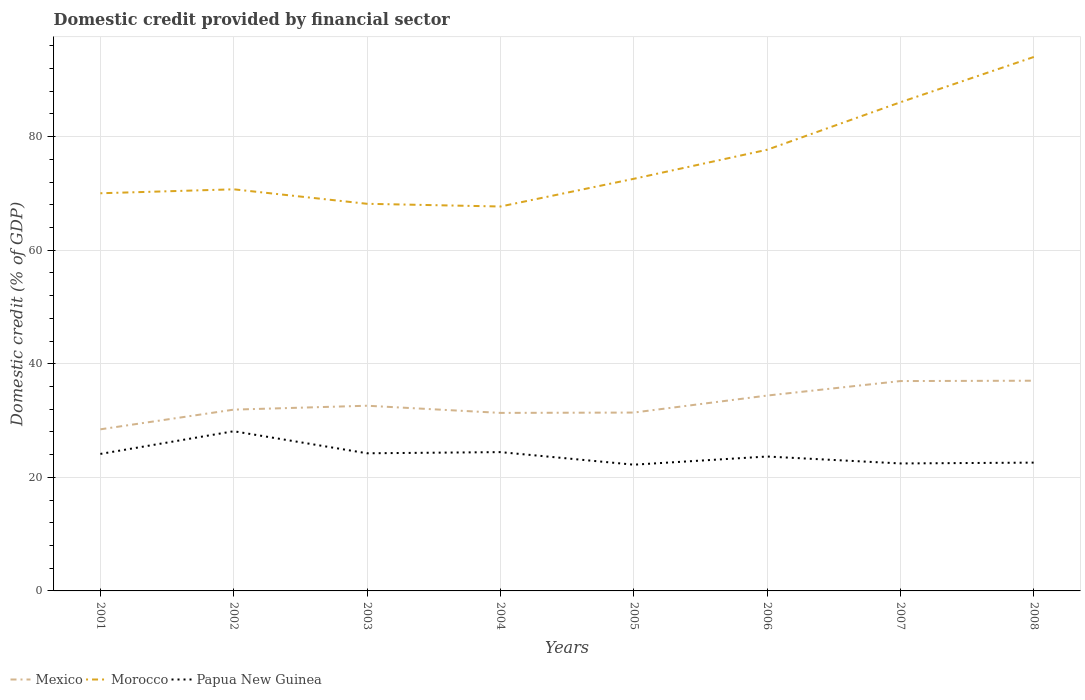Does the line corresponding to Morocco intersect with the line corresponding to Mexico?
Give a very brief answer. No. Across all years, what is the maximum domestic credit in Mexico?
Your response must be concise. 28.46. In which year was the domestic credit in Mexico maximum?
Your answer should be very brief. 2001. What is the total domestic credit in Morocco in the graph?
Give a very brief answer. -16.03. What is the difference between the highest and the second highest domestic credit in Morocco?
Make the answer very short. 26.33. What is the difference between the highest and the lowest domestic credit in Mexico?
Make the answer very short. 3. Is the domestic credit in Mexico strictly greater than the domestic credit in Papua New Guinea over the years?
Provide a succinct answer. No. How many lines are there?
Offer a terse response. 3. Are the values on the major ticks of Y-axis written in scientific E-notation?
Provide a short and direct response. No. Does the graph contain any zero values?
Give a very brief answer. No. Where does the legend appear in the graph?
Your response must be concise. Bottom left. How are the legend labels stacked?
Keep it short and to the point. Horizontal. What is the title of the graph?
Give a very brief answer. Domestic credit provided by financial sector. Does "Northern Mariana Islands" appear as one of the legend labels in the graph?
Give a very brief answer. No. What is the label or title of the X-axis?
Give a very brief answer. Years. What is the label or title of the Y-axis?
Provide a succinct answer. Domestic credit (% of GDP). What is the Domestic credit (% of GDP) of Mexico in 2001?
Provide a short and direct response. 28.46. What is the Domestic credit (% of GDP) of Morocco in 2001?
Your answer should be compact. 70.02. What is the Domestic credit (% of GDP) in Papua New Guinea in 2001?
Provide a succinct answer. 24.13. What is the Domestic credit (% of GDP) in Mexico in 2002?
Give a very brief answer. 31.92. What is the Domestic credit (% of GDP) of Morocco in 2002?
Your answer should be very brief. 70.72. What is the Domestic credit (% of GDP) of Papua New Guinea in 2002?
Your answer should be very brief. 28.12. What is the Domestic credit (% of GDP) in Mexico in 2003?
Offer a very short reply. 32.61. What is the Domestic credit (% of GDP) of Morocco in 2003?
Provide a short and direct response. 68.17. What is the Domestic credit (% of GDP) in Papua New Guinea in 2003?
Provide a succinct answer. 24.24. What is the Domestic credit (% of GDP) in Mexico in 2004?
Your answer should be compact. 31.35. What is the Domestic credit (% of GDP) of Morocco in 2004?
Keep it short and to the point. 67.69. What is the Domestic credit (% of GDP) of Papua New Guinea in 2004?
Your answer should be compact. 24.44. What is the Domestic credit (% of GDP) in Mexico in 2005?
Make the answer very short. 31.41. What is the Domestic credit (% of GDP) in Morocco in 2005?
Offer a terse response. 72.57. What is the Domestic credit (% of GDP) in Papua New Guinea in 2005?
Ensure brevity in your answer.  22.23. What is the Domestic credit (% of GDP) of Mexico in 2006?
Offer a terse response. 34.4. What is the Domestic credit (% of GDP) of Morocco in 2006?
Provide a short and direct response. 77.68. What is the Domestic credit (% of GDP) in Papua New Guinea in 2006?
Your answer should be very brief. 23.67. What is the Domestic credit (% of GDP) in Mexico in 2007?
Your answer should be very brief. 36.95. What is the Domestic credit (% of GDP) of Morocco in 2007?
Give a very brief answer. 86.05. What is the Domestic credit (% of GDP) in Papua New Guinea in 2007?
Provide a short and direct response. 22.45. What is the Domestic credit (% of GDP) of Mexico in 2008?
Offer a very short reply. 37.02. What is the Domestic credit (% of GDP) of Morocco in 2008?
Make the answer very short. 94.02. What is the Domestic credit (% of GDP) in Papua New Guinea in 2008?
Your answer should be compact. 22.59. Across all years, what is the maximum Domestic credit (% of GDP) of Mexico?
Keep it short and to the point. 37.02. Across all years, what is the maximum Domestic credit (% of GDP) of Morocco?
Provide a succinct answer. 94.02. Across all years, what is the maximum Domestic credit (% of GDP) in Papua New Guinea?
Ensure brevity in your answer.  28.12. Across all years, what is the minimum Domestic credit (% of GDP) in Mexico?
Keep it short and to the point. 28.46. Across all years, what is the minimum Domestic credit (% of GDP) of Morocco?
Provide a succinct answer. 67.69. Across all years, what is the minimum Domestic credit (% of GDP) of Papua New Guinea?
Provide a short and direct response. 22.23. What is the total Domestic credit (% of GDP) in Mexico in the graph?
Your answer should be very brief. 264.11. What is the total Domestic credit (% of GDP) in Morocco in the graph?
Make the answer very short. 606.93. What is the total Domestic credit (% of GDP) in Papua New Guinea in the graph?
Your response must be concise. 191.85. What is the difference between the Domestic credit (% of GDP) in Mexico in 2001 and that in 2002?
Your answer should be very brief. -3.47. What is the difference between the Domestic credit (% of GDP) of Morocco in 2001 and that in 2002?
Offer a terse response. -0.7. What is the difference between the Domestic credit (% of GDP) in Papua New Guinea in 2001 and that in 2002?
Provide a succinct answer. -3.99. What is the difference between the Domestic credit (% of GDP) of Mexico in 2001 and that in 2003?
Your response must be concise. -4.15. What is the difference between the Domestic credit (% of GDP) of Morocco in 2001 and that in 2003?
Make the answer very short. 1.86. What is the difference between the Domestic credit (% of GDP) of Papua New Guinea in 2001 and that in 2003?
Provide a succinct answer. -0.11. What is the difference between the Domestic credit (% of GDP) of Mexico in 2001 and that in 2004?
Provide a succinct answer. -2.89. What is the difference between the Domestic credit (% of GDP) of Morocco in 2001 and that in 2004?
Ensure brevity in your answer.  2.33. What is the difference between the Domestic credit (% of GDP) of Papua New Guinea in 2001 and that in 2004?
Give a very brief answer. -0.32. What is the difference between the Domestic credit (% of GDP) of Mexico in 2001 and that in 2005?
Your answer should be compact. -2.95. What is the difference between the Domestic credit (% of GDP) of Morocco in 2001 and that in 2005?
Your response must be concise. -2.54. What is the difference between the Domestic credit (% of GDP) of Papua New Guinea in 2001 and that in 2005?
Provide a short and direct response. 1.9. What is the difference between the Domestic credit (% of GDP) of Mexico in 2001 and that in 2006?
Keep it short and to the point. -5.94. What is the difference between the Domestic credit (% of GDP) of Morocco in 2001 and that in 2006?
Give a very brief answer. -7.66. What is the difference between the Domestic credit (% of GDP) in Papua New Guinea in 2001 and that in 2006?
Give a very brief answer. 0.46. What is the difference between the Domestic credit (% of GDP) of Mexico in 2001 and that in 2007?
Offer a terse response. -8.5. What is the difference between the Domestic credit (% of GDP) in Morocco in 2001 and that in 2007?
Make the answer very short. -16.03. What is the difference between the Domestic credit (% of GDP) in Papua New Guinea in 2001 and that in 2007?
Keep it short and to the point. 1.68. What is the difference between the Domestic credit (% of GDP) of Mexico in 2001 and that in 2008?
Provide a succinct answer. -8.56. What is the difference between the Domestic credit (% of GDP) in Morocco in 2001 and that in 2008?
Ensure brevity in your answer.  -24. What is the difference between the Domestic credit (% of GDP) of Papua New Guinea in 2001 and that in 2008?
Ensure brevity in your answer.  1.53. What is the difference between the Domestic credit (% of GDP) in Mexico in 2002 and that in 2003?
Ensure brevity in your answer.  -0.69. What is the difference between the Domestic credit (% of GDP) in Morocco in 2002 and that in 2003?
Keep it short and to the point. 2.55. What is the difference between the Domestic credit (% of GDP) in Papua New Guinea in 2002 and that in 2003?
Ensure brevity in your answer.  3.88. What is the difference between the Domestic credit (% of GDP) in Mexico in 2002 and that in 2004?
Keep it short and to the point. 0.58. What is the difference between the Domestic credit (% of GDP) in Morocco in 2002 and that in 2004?
Your answer should be very brief. 3.03. What is the difference between the Domestic credit (% of GDP) of Papua New Guinea in 2002 and that in 2004?
Provide a short and direct response. 3.68. What is the difference between the Domestic credit (% of GDP) in Mexico in 2002 and that in 2005?
Offer a terse response. 0.52. What is the difference between the Domestic credit (% of GDP) in Morocco in 2002 and that in 2005?
Your answer should be compact. -1.85. What is the difference between the Domestic credit (% of GDP) in Papua New Guinea in 2002 and that in 2005?
Your response must be concise. 5.89. What is the difference between the Domestic credit (% of GDP) in Mexico in 2002 and that in 2006?
Your answer should be very brief. -2.48. What is the difference between the Domestic credit (% of GDP) of Morocco in 2002 and that in 2006?
Your response must be concise. -6.97. What is the difference between the Domestic credit (% of GDP) in Papua New Guinea in 2002 and that in 2006?
Your response must be concise. 4.45. What is the difference between the Domestic credit (% of GDP) of Mexico in 2002 and that in 2007?
Your response must be concise. -5.03. What is the difference between the Domestic credit (% of GDP) of Morocco in 2002 and that in 2007?
Give a very brief answer. -15.33. What is the difference between the Domestic credit (% of GDP) of Papua New Guinea in 2002 and that in 2007?
Offer a terse response. 5.67. What is the difference between the Domestic credit (% of GDP) of Mexico in 2002 and that in 2008?
Give a very brief answer. -5.09. What is the difference between the Domestic credit (% of GDP) of Morocco in 2002 and that in 2008?
Your answer should be compact. -23.3. What is the difference between the Domestic credit (% of GDP) in Papua New Guinea in 2002 and that in 2008?
Give a very brief answer. 5.53. What is the difference between the Domestic credit (% of GDP) in Mexico in 2003 and that in 2004?
Provide a short and direct response. 1.26. What is the difference between the Domestic credit (% of GDP) of Morocco in 2003 and that in 2004?
Your answer should be compact. 0.48. What is the difference between the Domestic credit (% of GDP) in Papua New Guinea in 2003 and that in 2004?
Your response must be concise. -0.21. What is the difference between the Domestic credit (% of GDP) in Mexico in 2003 and that in 2005?
Ensure brevity in your answer.  1.2. What is the difference between the Domestic credit (% of GDP) in Morocco in 2003 and that in 2005?
Offer a very short reply. -4.4. What is the difference between the Domestic credit (% of GDP) in Papua New Guinea in 2003 and that in 2005?
Your response must be concise. 2.01. What is the difference between the Domestic credit (% of GDP) in Mexico in 2003 and that in 2006?
Provide a succinct answer. -1.79. What is the difference between the Domestic credit (% of GDP) in Morocco in 2003 and that in 2006?
Make the answer very short. -9.52. What is the difference between the Domestic credit (% of GDP) in Papua New Guinea in 2003 and that in 2006?
Offer a terse response. 0.57. What is the difference between the Domestic credit (% of GDP) in Mexico in 2003 and that in 2007?
Offer a terse response. -4.34. What is the difference between the Domestic credit (% of GDP) in Morocco in 2003 and that in 2007?
Your answer should be very brief. -17.88. What is the difference between the Domestic credit (% of GDP) of Papua New Guinea in 2003 and that in 2007?
Ensure brevity in your answer.  1.79. What is the difference between the Domestic credit (% of GDP) of Mexico in 2003 and that in 2008?
Give a very brief answer. -4.41. What is the difference between the Domestic credit (% of GDP) of Morocco in 2003 and that in 2008?
Provide a succinct answer. -25.86. What is the difference between the Domestic credit (% of GDP) of Papua New Guinea in 2003 and that in 2008?
Keep it short and to the point. 1.64. What is the difference between the Domestic credit (% of GDP) of Mexico in 2004 and that in 2005?
Provide a succinct answer. -0.06. What is the difference between the Domestic credit (% of GDP) in Morocco in 2004 and that in 2005?
Your response must be concise. -4.88. What is the difference between the Domestic credit (% of GDP) in Papua New Guinea in 2004 and that in 2005?
Offer a very short reply. 2.21. What is the difference between the Domestic credit (% of GDP) of Mexico in 2004 and that in 2006?
Keep it short and to the point. -3.05. What is the difference between the Domestic credit (% of GDP) of Morocco in 2004 and that in 2006?
Offer a very short reply. -9.99. What is the difference between the Domestic credit (% of GDP) of Papua New Guinea in 2004 and that in 2006?
Provide a short and direct response. 0.78. What is the difference between the Domestic credit (% of GDP) of Mexico in 2004 and that in 2007?
Your response must be concise. -5.61. What is the difference between the Domestic credit (% of GDP) of Morocco in 2004 and that in 2007?
Your response must be concise. -18.36. What is the difference between the Domestic credit (% of GDP) of Papua New Guinea in 2004 and that in 2007?
Provide a succinct answer. 1.99. What is the difference between the Domestic credit (% of GDP) in Mexico in 2004 and that in 2008?
Your response must be concise. -5.67. What is the difference between the Domestic credit (% of GDP) in Morocco in 2004 and that in 2008?
Make the answer very short. -26.33. What is the difference between the Domestic credit (% of GDP) of Papua New Guinea in 2004 and that in 2008?
Offer a very short reply. 1.85. What is the difference between the Domestic credit (% of GDP) of Mexico in 2005 and that in 2006?
Provide a short and direct response. -2.99. What is the difference between the Domestic credit (% of GDP) in Morocco in 2005 and that in 2006?
Offer a very short reply. -5.12. What is the difference between the Domestic credit (% of GDP) in Papua New Guinea in 2005 and that in 2006?
Offer a terse response. -1.44. What is the difference between the Domestic credit (% of GDP) of Mexico in 2005 and that in 2007?
Your response must be concise. -5.55. What is the difference between the Domestic credit (% of GDP) of Morocco in 2005 and that in 2007?
Give a very brief answer. -13.48. What is the difference between the Domestic credit (% of GDP) of Papua New Guinea in 2005 and that in 2007?
Keep it short and to the point. -0.22. What is the difference between the Domestic credit (% of GDP) in Mexico in 2005 and that in 2008?
Keep it short and to the point. -5.61. What is the difference between the Domestic credit (% of GDP) of Morocco in 2005 and that in 2008?
Your response must be concise. -21.46. What is the difference between the Domestic credit (% of GDP) of Papua New Guinea in 2005 and that in 2008?
Provide a succinct answer. -0.36. What is the difference between the Domestic credit (% of GDP) of Mexico in 2006 and that in 2007?
Ensure brevity in your answer.  -2.55. What is the difference between the Domestic credit (% of GDP) in Morocco in 2006 and that in 2007?
Give a very brief answer. -8.37. What is the difference between the Domestic credit (% of GDP) in Papua New Guinea in 2006 and that in 2007?
Keep it short and to the point. 1.22. What is the difference between the Domestic credit (% of GDP) of Mexico in 2006 and that in 2008?
Make the answer very short. -2.62. What is the difference between the Domestic credit (% of GDP) in Morocco in 2006 and that in 2008?
Your answer should be very brief. -16.34. What is the difference between the Domestic credit (% of GDP) in Papua New Guinea in 2006 and that in 2008?
Your response must be concise. 1.07. What is the difference between the Domestic credit (% of GDP) of Mexico in 2007 and that in 2008?
Offer a very short reply. -0.06. What is the difference between the Domestic credit (% of GDP) of Morocco in 2007 and that in 2008?
Provide a succinct answer. -7.97. What is the difference between the Domestic credit (% of GDP) in Papua New Guinea in 2007 and that in 2008?
Provide a succinct answer. -0.15. What is the difference between the Domestic credit (% of GDP) of Mexico in 2001 and the Domestic credit (% of GDP) of Morocco in 2002?
Offer a very short reply. -42.26. What is the difference between the Domestic credit (% of GDP) in Mexico in 2001 and the Domestic credit (% of GDP) in Papua New Guinea in 2002?
Your response must be concise. 0.34. What is the difference between the Domestic credit (% of GDP) in Morocco in 2001 and the Domestic credit (% of GDP) in Papua New Guinea in 2002?
Offer a terse response. 41.9. What is the difference between the Domestic credit (% of GDP) of Mexico in 2001 and the Domestic credit (% of GDP) of Morocco in 2003?
Give a very brief answer. -39.71. What is the difference between the Domestic credit (% of GDP) of Mexico in 2001 and the Domestic credit (% of GDP) of Papua New Guinea in 2003?
Make the answer very short. 4.22. What is the difference between the Domestic credit (% of GDP) in Morocco in 2001 and the Domestic credit (% of GDP) in Papua New Guinea in 2003?
Keep it short and to the point. 45.79. What is the difference between the Domestic credit (% of GDP) in Mexico in 2001 and the Domestic credit (% of GDP) in Morocco in 2004?
Your response must be concise. -39.23. What is the difference between the Domestic credit (% of GDP) in Mexico in 2001 and the Domestic credit (% of GDP) in Papua New Guinea in 2004?
Offer a very short reply. 4.01. What is the difference between the Domestic credit (% of GDP) of Morocco in 2001 and the Domestic credit (% of GDP) of Papua New Guinea in 2004?
Offer a very short reply. 45.58. What is the difference between the Domestic credit (% of GDP) of Mexico in 2001 and the Domestic credit (% of GDP) of Morocco in 2005?
Make the answer very short. -44.11. What is the difference between the Domestic credit (% of GDP) in Mexico in 2001 and the Domestic credit (% of GDP) in Papua New Guinea in 2005?
Offer a terse response. 6.23. What is the difference between the Domestic credit (% of GDP) of Morocco in 2001 and the Domestic credit (% of GDP) of Papua New Guinea in 2005?
Ensure brevity in your answer.  47.79. What is the difference between the Domestic credit (% of GDP) in Mexico in 2001 and the Domestic credit (% of GDP) in Morocco in 2006?
Offer a terse response. -49.23. What is the difference between the Domestic credit (% of GDP) in Mexico in 2001 and the Domestic credit (% of GDP) in Papua New Guinea in 2006?
Your response must be concise. 4.79. What is the difference between the Domestic credit (% of GDP) of Morocco in 2001 and the Domestic credit (% of GDP) of Papua New Guinea in 2006?
Ensure brevity in your answer.  46.36. What is the difference between the Domestic credit (% of GDP) of Mexico in 2001 and the Domestic credit (% of GDP) of Morocco in 2007?
Offer a very short reply. -57.6. What is the difference between the Domestic credit (% of GDP) in Mexico in 2001 and the Domestic credit (% of GDP) in Papua New Guinea in 2007?
Keep it short and to the point. 6.01. What is the difference between the Domestic credit (% of GDP) in Morocco in 2001 and the Domestic credit (% of GDP) in Papua New Guinea in 2007?
Your response must be concise. 47.58. What is the difference between the Domestic credit (% of GDP) of Mexico in 2001 and the Domestic credit (% of GDP) of Morocco in 2008?
Provide a short and direct response. -65.57. What is the difference between the Domestic credit (% of GDP) of Mexico in 2001 and the Domestic credit (% of GDP) of Papua New Guinea in 2008?
Your answer should be very brief. 5.86. What is the difference between the Domestic credit (% of GDP) of Morocco in 2001 and the Domestic credit (% of GDP) of Papua New Guinea in 2008?
Your answer should be compact. 47.43. What is the difference between the Domestic credit (% of GDP) in Mexico in 2002 and the Domestic credit (% of GDP) in Morocco in 2003?
Offer a very short reply. -36.24. What is the difference between the Domestic credit (% of GDP) of Mexico in 2002 and the Domestic credit (% of GDP) of Papua New Guinea in 2003?
Ensure brevity in your answer.  7.69. What is the difference between the Domestic credit (% of GDP) in Morocco in 2002 and the Domestic credit (% of GDP) in Papua New Guinea in 2003?
Give a very brief answer. 46.48. What is the difference between the Domestic credit (% of GDP) in Mexico in 2002 and the Domestic credit (% of GDP) in Morocco in 2004?
Offer a terse response. -35.77. What is the difference between the Domestic credit (% of GDP) of Mexico in 2002 and the Domestic credit (% of GDP) of Papua New Guinea in 2004?
Offer a very short reply. 7.48. What is the difference between the Domestic credit (% of GDP) in Morocco in 2002 and the Domestic credit (% of GDP) in Papua New Guinea in 2004?
Offer a very short reply. 46.28. What is the difference between the Domestic credit (% of GDP) of Mexico in 2002 and the Domestic credit (% of GDP) of Morocco in 2005?
Provide a succinct answer. -40.64. What is the difference between the Domestic credit (% of GDP) in Mexico in 2002 and the Domestic credit (% of GDP) in Papua New Guinea in 2005?
Ensure brevity in your answer.  9.69. What is the difference between the Domestic credit (% of GDP) of Morocco in 2002 and the Domestic credit (% of GDP) of Papua New Guinea in 2005?
Keep it short and to the point. 48.49. What is the difference between the Domestic credit (% of GDP) of Mexico in 2002 and the Domestic credit (% of GDP) of Morocco in 2006?
Provide a short and direct response. -45.76. What is the difference between the Domestic credit (% of GDP) in Mexico in 2002 and the Domestic credit (% of GDP) in Papua New Guinea in 2006?
Offer a terse response. 8.26. What is the difference between the Domestic credit (% of GDP) in Morocco in 2002 and the Domestic credit (% of GDP) in Papua New Guinea in 2006?
Your answer should be very brief. 47.05. What is the difference between the Domestic credit (% of GDP) in Mexico in 2002 and the Domestic credit (% of GDP) in Morocco in 2007?
Offer a terse response. -54.13. What is the difference between the Domestic credit (% of GDP) in Mexico in 2002 and the Domestic credit (% of GDP) in Papua New Guinea in 2007?
Ensure brevity in your answer.  9.48. What is the difference between the Domestic credit (% of GDP) of Morocco in 2002 and the Domestic credit (% of GDP) of Papua New Guinea in 2007?
Give a very brief answer. 48.27. What is the difference between the Domestic credit (% of GDP) in Mexico in 2002 and the Domestic credit (% of GDP) in Morocco in 2008?
Offer a very short reply. -62.1. What is the difference between the Domestic credit (% of GDP) of Mexico in 2002 and the Domestic credit (% of GDP) of Papua New Guinea in 2008?
Your response must be concise. 9.33. What is the difference between the Domestic credit (% of GDP) of Morocco in 2002 and the Domestic credit (% of GDP) of Papua New Guinea in 2008?
Offer a very short reply. 48.13. What is the difference between the Domestic credit (% of GDP) in Mexico in 2003 and the Domestic credit (% of GDP) in Morocco in 2004?
Provide a succinct answer. -35.08. What is the difference between the Domestic credit (% of GDP) of Mexico in 2003 and the Domestic credit (% of GDP) of Papua New Guinea in 2004?
Offer a very short reply. 8.17. What is the difference between the Domestic credit (% of GDP) of Morocco in 2003 and the Domestic credit (% of GDP) of Papua New Guinea in 2004?
Make the answer very short. 43.73. What is the difference between the Domestic credit (% of GDP) of Mexico in 2003 and the Domestic credit (% of GDP) of Morocco in 2005?
Keep it short and to the point. -39.96. What is the difference between the Domestic credit (% of GDP) in Mexico in 2003 and the Domestic credit (% of GDP) in Papua New Guinea in 2005?
Provide a succinct answer. 10.38. What is the difference between the Domestic credit (% of GDP) of Morocco in 2003 and the Domestic credit (% of GDP) of Papua New Guinea in 2005?
Your response must be concise. 45.94. What is the difference between the Domestic credit (% of GDP) of Mexico in 2003 and the Domestic credit (% of GDP) of Morocco in 2006?
Your answer should be very brief. -45.07. What is the difference between the Domestic credit (% of GDP) of Mexico in 2003 and the Domestic credit (% of GDP) of Papua New Guinea in 2006?
Provide a short and direct response. 8.94. What is the difference between the Domestic credit (% of GDP) in Morocco in 2003 and the Domestic credit (% of GDP) in Papua New Guinea in 2006?
Offer a very short reply. 44.5. What is the difference between the Domestic credit (% of GDP) of Mexico in 2003 and the Domestic credit (% of GDP) of Morocco in 2007?
Offer a terse response. -53.44. What is the difference between the Domestic credit (% of GDP) in Mexico in 2003 and the Domestic credit (% of GDP) in Papua New Guinea in 2007?
Make the answer very short. 10.16. What is the difference between the Domestic credit (% of GDP) in Morocco in 2003 and the Domestic credit (% of GDP) in Papua New Guinea in 2007?
Provide a succinct answer. 45.72. What is the difference between the Domestic credit (% of GDP) in Mexico in 2003 and the Domestic credit (% of GDP) in Morocco in 2008?
Provide a succinct answer. -61.41. What is the difference between the Domestic credit (% of GDP) of Mexico in 2003 and the Domestic credit (% of GDP) of Papua New Guinea in 2008?
Provide a short and direct response. 10.02. What is the difference between the Domestic credit (% of GDP) of Morocco in 2003 and the Domestic credit (% of GDP) of Papua New Guinea in 2008?
Offer a terse response. 45.58. What is the difference between the Domestic credit (% of GDP) in Mexico in 2004 and the Domestic credit (% of GDP) in Morocco in 2005?
Your response must be concise. -41.22. What is the difference between the Domestic credit (% of GDP) of Mexico in 2004 and the Domestic credit (% of GDP) of Papua New Guinea in 2005?
Make the answer very short. 9.12. What is the difference between the Domestic credit (% of GDP) of Morocco in 2004 and the Domestic credit (% of GDP) of Papua New Guinea in 2005?
Give a very brief answer. 45.46. What is the difference between the Domestic credit (% of GDP) of Mexico in 2004 and the Domestic credit (% of GDP) of Morocco in 2006?
Your response must be concise. -46.34. What is the difference between the Domestic credit (% of GDP) in Mexico in 2004 and the Domestic credit (% of GDP) in Papua New Guinea in 2006?
Offer a terse response. 7.68. What is the difference between the Domestic credit (% of GDP) in Morocco in 2004 and the Domestic credit (% of GDP) in Papua New Guinea in 2006?
Your answer should be very brief. 44.02. What is the difference between the Domestic credit (% of GDP) in Mexico in 2004 and the Domestic credit (% of GDP) in Morocco in 2007?
Offer a terse response. -54.7. What is the difference between the Domestic credit (% of GDP) in Mexico in 2004 and the Domestic credit (% of GDP) in Papua New Guinea in 2007?
Keep it short and to the point. 8.9. What is the difference between the Domestic credit (% of GDP) in Morocco in 2004 and the Domestic credit (% of GDP) in Papua New Guinea in 2007?
Make the answer very short. 45.24. What is the difference between the Domestic credit (% of GDP) in Mexico in 2004 and the Domestic credit (% of GDP) in Morocco in 2008?
Make the answer very short. -62.68. What is the difference between the Domestic credit (% of GDP) of Mexico in 2004 and the Domestic credit (% of GDP) of Papua New Guinea in 2008?
Ensure brevity in your answer.  8.76. What is the difference between the Domestic credit (% of GDP) of Morocco in 2004 and the Domestic credit (% of GDP) of Papua New Guinea in 2008?
Keep it short and to the point. 45.1. What is the difference between the Domestic credit (% of GDP) in Mexico in 2005 and the Domestic credit (% of GDP) in Morocco in 2006?
Your answer should be compact. -46.28. What is the difference between the Domestic credit (% of GDP) of Mexico in 2005 and the Domestic credit (% of GDP) of Papua New Guinea in 2006?
Offer a very short reply. 7.74. What is the difference between the Domestic credit (% of GDP) in Morocco in 2005 and the Domestic credit (% of GDP) in Papua New Guinea in 2006?
Provide a short and direct response. 48.9. What is the difference between the Domestic credit (% of GDP) in Mexico in 2005 and the Domestic credit (% of GDP) in Morocco in 2007?
Your response must be concise. -54.65. What is the difference between the Domestic credit (% of GDP) of Mexico in 2005 and the Domestic credit (% of GDP) of Papua New Guinea in 2007?
Your answer should be very brief. 8.96. What is the difference between the Domestic credit (% of GDP) in Morocco in 2005 and the Domestic credit (% of GDP) in Papua New Guinea in 2007?
Give a very brief answer. 50.12. What is the difference between the Domestic credit (% of GDP) in Mexico in 2005 and the Domestic credit (% of GDP) in Morocco in 2008?
Keep it short and to the point. -62.62. What is the difference between the Domestic credit (% of GDP) of Mexico in 2005 and the Domestic credit (% of GDP) of Papua New Guinea in 2008?
Keep it short and to the point. 8.81. What is the difference between the Domestic credit (% of GDP) of Morocco in 2005 and the Domestic credit (% of GDP) of Papua New Guinea in 2008?
Give a very brief answer. 49.98. What is the difference between the Domestic credit (% of GDP) of Mexico in 2006 and the Domestic credit (% of GDP) of Morocco in 2007?
Provide a short and direct response. -51.65. What is the difference between the Domestic credit (% of GDP) of Mexico in 2006 and the Domestic credit (% of GDP) of Papua New Guinea in 2007?
Your response must be concise. 11.95. What is the difference between the Domestic credit (% of GDP) of Morocco in 2006 and the Domestic credit (% of GDP) of Papua New Guinea in 2007?
Provide a short and direct response. 55.24. What is the difference between the Domestic credit (% of GDP) of Mexico in 2006 and the Domestic credit (% of GDP) of Morocco in 2008?
Offer a terse response. -59.62. What is the difference between the Domestic credit (% of GDP) of Mexico in 2006 and the Domestic credit (% of GDP) of Papua New Guinea in 2008?
Your response must be concise. 11.81. What is the difference between the Domestic credit (% of GDP) in Morocco in 2006 and the Domestic credit (% of GDP) in Papua New Guinea in 2008?
Keep it short and to the point. 55.09. What is the difference between the Domestic credit (% of GDP) of Mexico in 2007 and the Domestic credit (% of GDP) of Morocco in 2008?
Make the answer very short. -57.07. What is the difference between the Domestic credit (% of GDP) of Mexico in 2007 and the Domestic credit (% of GDP) of Papua New Guinea in 2008?
Offer a very short reply. 14.36. What is the difference between the Domestic credit (% of GDP) of Morocco in 2007 and the Domestic credit (% of GDP) of Papua New Guinea in 2008?
Ensure brevity in your answer.  63.46. What is the average Domestic credit (% of GDP) of Mexico per year?
Offer a terse response. 33.01. What is the average Domestic credit (% of GDP) of Morocco per year?
Offer a terse response. 75.87. What is the average Domestic credit (% of GDP) of Papua New Guinea per year?
Keep it short and to the point. 23.98. In the year 2001, what is the difference between the Domestic credit (% of GDP) in Mexico and Domestic credit (% of GDP) in Morocco?
Make the answer very short. -41.57. In the year 2001, what is the difference between the Domestic credit (% of GDP) in Mexico and Domestic credit (% of GDP) in Papua New Guinea?
Give a very brief answer. 4.33. In the year 2001, what is the difference between the Domestic credit (% of GDP) of Morocco and Domestic credit (% of GDP) of Papua New Guinea?
Your response must be concise. 45.9. In the year 2002, what is the difference between the Domestic credit (% of GDP) in Mexico and Domestic credit (% of GDP) in Morocco?
Offer a terse response. -38.8. In the year 2002, what is the difference between the Domestic credit (% of GDP) in Mexico and Domestic credit (% of GDP) in Papua New Guinea?
Offer a terse response. 3.8. In the year 2002, what is the difference between the Domestic credit (% of GDP) in Morocco and Domestic credit (% of GDP) in Papua New Guinea?
Offer a very short reply. 42.6. In the year 2003, what is the difference between the Domestic credit (% of GDP) of Mexico and Domestic credit (% of GDP) of Morocco?
Offer a very short reply. -35.56. In the year 2003, what is the difference between the Domestic credit (% of GDP) in Mexico and Domestic credit (% of GDP) in Papua New Guinea?
Provide a succinct answer. 8.38. In the year 2003, what is the difference between the Domestic credit (% of GDP) of Morocco and Domestic credit (% of GDP) of Papua New Guinea?
Provide a short and direct response. 43.93. In the year 2004, what is the difference between the Domestic credit (% of GDP) in Mexico and Domestic credit (% of GDP) in Morocco?
Provide a succinct answer. -36.34. In the year 2004, what is the difference between the Domestic credit (% of GDP) of Mexico and Domestic credit (% of GDP) of Papua New Guinea?
Your answer should be compact. 6.91. In the year 2004, what is the difference between the Domestic credit (% of GDP) of Morocco and Domestic credit (% of GDP) of Papua New Guinea?
Provide a short and direct response. 43.25. In the year 2005, what is the difference between the Domestic credit (% of GDP) of Mexico and Domestic credit (% of GDP) of Morocco?
Offer a terse response. -41.16. In the year 2005, what is the difference between the Domestic credit (% of GDP) of Mexico and Domestic credit (% of GDP) of Papua New Guinea?
Provide a short and direct response. 9.18. In the year 2005, what is the difference between the Domestic credit (% of GDP) of Morocco and Domestic credit (% of GDP) of Papua New Guinea?
Your response must be concise. 50.34. In the year 2006, what is the difference between the Domestic credit (% of GDP) in Mexico and Domestic credit (% of GDP) in Morocco?
Make the answer very short. -43.28. In the year 2006, what is the difference between the Domestic credit (% of GDP) of Mexico and Domestic credit (% of GDP) of Papua New Guinea?
Offer a very short reply. 10.73. In the year 2006, what is the difference between the Domestic credit (% of GDP) in Morocco and Domestic credit (% of GDP) in Papua New Guinea?
Your answer should be compact. 54.02. In the year 2007, what is the difference between the Domestic credit (% of GDP) in Mexico and Domestic credit (% of GDP) in Morocco?
Provide a succinct answer. -49.1. In the year 2007, what is the difference between the Domestic credit (% of GDP) of Mexico and Domestic credit (% of GDP) of Papua New Guinea?
Offer a very short reply. 14.51. In the year 2007, what is the difference between the Domestic credit (% of GDP) of Morocco and Domestic credit (% of GDP) of Papua New Guinea?
Ensure brevity in your answer.  63.61. In the year 2008, what is the difference between the Domestic credit (% of GDP) in Mexico and Domestic credit (% of GDP) in Morocco?
Your answer should be very brief. -57.01. In the year 2008, what is the difference between the Domestic credit (% of GDP) in Mexico and Domestic credit (% of GDP) in Papua New Guinea?
Your answer should be very brief. 14.42. In the year 2008, what is the difference between the Domestic credit (% of GDP) in Morocco and Domestic credit (% of GDP) in Papua New Guinea?
Provide a succinct answer. 71.43. What is the ratio of the Domestic credit (% of GDP) in Mexico in 2001 to that in 2002?
Provide a short and direct response. 0.89. What is the ratio of the Domestic credit (% of GDP) of Morocco in 2001 to that in 2002?
Offer a terse response. 0.99. What is the ratio of the Domestic credit (% of GDP) of Papua New Guinea in 2001 to that in 2002?
Offer a terse response. 0.86. What is the ratio of the Domestic credit (% of GDP) in Mexico in 2001 to that in 2003?
Give a very brief answer. 0.87. What is the ratio of the Domestic credit (% of GDP) in Morocco in 2001 to that in 2003?
Your response must be concise. 1.03. What is the ratio of the Domestic credit (% of GDP) in Mexico in 2001 to that in 2004?
Provide a short and direct response. 0.91. What is the ratio of the Domestic credit (% of GDP) of Morocco in 2001 to that in 2004?
Your answer should be very brief. 1.03. What is the ratio of the Domestic credit (% of GDP) of Papua New Guinea in 2001 to that in 2004?
Your answer should be compact. 0.99. What is the ratio of the Domestic credit (% of GDP) in Mexico in 2001 to that in 2005?
Provide a succinct answer. 0.91. What is the ratio of the Domestic credit (% of GDP) of Morocco in 2001 to that in 2005?
Offer a very short reply. 0.96. What is the ratio of the Domestic credit (% of GDP) in Papua New Guinea in 2001 to that in 2005?
Provide a short and direct response. 1.09. What is the ratio of the Domestic credit (% of GDP) of Mexico in 2001 to that in 2006?
Ensure brevity in your answer.  0.83. What is the ratio of the Domestic credit (% of GDP) in Morocco in 2001 to that in 2006?
Give a very brief answer. 0.9. What is the ratio of the Domestic credit (% of GDP) in Papua New Guinea in 2001 to that in 2006?
Your answer should be compact. 1.02. What is the ratio of the Domestic credit (% of GDP) of Mexico in 2001 to that in 2007?
Keep it short and to the point. 0.77. What is the ratio of the Domestic credit (% of GDP) of Morocco in 2001 to that in 2007?
Offer a terse response. 0.81. What is the ratio of the Domestic credit (% of GDP) of Papua New Guinea in 2001 to that in 2007?
Your answer should be compact. 1.07. What is the ratio of the Domestic credit (% of GDP) of Mexico in 2001 to that in 2008?
Ensure brevity in your answer.  0.77. What is the ratio of the Domestic credit (% of GDP) in Morocco in 2001 to that in 2008?
Your answer should be very brief. 0.74. What is the ratio of the Domestic credit (% of GDP) in Papua New Guinea in 2001 to that in 2008?
Provide a succinct answer. 1.07. What is the ratio of the Domestic credit (% of GDP) in Mexico in 2002 to that in 2003?
Offer a very short reply. 0.98. What is the ratio of the Domestic credit (% of GDP) in Morocco in 2002 to that in 2003?
Your answer should be very brief. 1.04. What is the ratio of the Domestic credit (% of GDP) of Papua New Guinea in 2002 to that in 2003?
Your answer should be very brief. 1.16. What is the ratio of the Domestic credit (% of GDP) of Mexico in 2002 to that in 2004?
Keep it short and to the point. 1.02. What is the ratio of the Domestic credit (% of GDP) of Morocco in 2002 to that in 2004?
Make the answer very short. 1.04. What is the ratio of the Domestic credit (% of GDP) of Papua New Guinea in 2002 to that in 2004?
Your response must be concise. 1.15. What is the ratio of the Domestic credit (% of GDP) of Mexico in 2002 to that in 2005?
Your answer should be compact. 1.02. What is the ratio of the Domestic credit (% of GDP) in Morocco in 2002 to that in 2005?
Offer a very short reply. 0.97. What is the ratio of the Domestic credit (% of GDP) of Papua New Guinea in 2002 to that in 2005?
Give a very brief answer. 1.26. What is the ratio of the Domestic credit (% of GDP) in Mexico in 2002 to that in 2006?
Your answer should be compact. 0.93. What is the ratio of the Domestic credit (% of GDP) in Morocco in 2002 to that in 2006?
Offer a terse response. 0.91. What is the ratio of the Domestic credit (% of GDP) of Papua New Guinea in 2002 to that in 2006?
Your response must be concise. 1.19. What is the ratio of the Domestic credit (% of GDP) of Mexico in 2002 to that in 2007?
Offer a very short reply. 0.86. What is the ratio of the Domestic credit (% of GDP) in Morocco in 2002 to that in 2007?
Keep it short and to the point. 0.82. What is the ratio of the Domestic credit (% of GDP) of Papua New Guinea in 2002 to that in 2007?
Your answer should be compact. 1.25. What is the ratio of the Domestic credit (% of GDP) of Mexico in 2002 to that in 2008?
Offer a very short reply. 0.86. What is the ratio of the Domestic credit (% of GDP) in Morocco in 2002 to that in 2008?
Your answer should be very brief. 0.75. What is the ratio of the Domestic credit (% of GDP) of Papua New Guinea in 2002 to that in 2008?
Provide a short and direct response. 1.24. What is the ratio of the Domestic credit (% of GDP) of Mexico in 2003 to that in 2004?
Your answer should be compact. 1.04. What is the ratio of the Domestic credit (% of GDP) in Morocco in 2003 to that in 2004?
Your response must be concise. 1.01. What is the ratio of the Domestic credit (% of GDP) in Mexico in 2003 to that in 2005?
Provide a succinct answer. 1.04. What is the ratio of the Domestic credit (% of GDP) in Morocco in 2003 to that in 2005?
Offer a very short reply. 0.94. What is the ratio of the Domestic credit (% of GDP) of Papua New Guinea in 2003 to that in 2005?
Your response must be concise. 1.09. What is the ratio of the Domestic credit (% of GDP) in Mexico in 2003 to that in 2006?
Ensure brevity in your answer.  0.95. What is the ratio of the Domestic credit (% of GDP) in Morocco in 2003 to that in 2006?
Provide a short and direct response. 0.88. What is the ratio of the Domestic credit (% of GDP) in Mexico in 2003 to that in 2007?
Ensure brevity in your answer.  0.88. What is the ratio of the Domestic credit (% of GDP) of Morocco in 2003 to that in 2007?
Give a very brief answer. 0.79. What is the ratio of the Domestic credit (% of GDP) in Papua New Guinea in 2003 to that in 2007?
Give a very brief answer. 1.08. What is the ratio of the Domestic credit (% of GDP) in Mexico in 2003 to that in 2008?
Ensure brevity in your answer.  0.88. What is the ratio of the Domestic credit (% of GDP) in Morocco in 2003 to that in 2008?
Offer a very short reply. 0.72. What is the ratio of the Domestic credit (% of GDP) of Papua New Guinea in 2003 to that in 2008?
Provide a short and direct response. 1.07. What is the ratio of the Domestic credit (% of GDP) in Mexico in 2004 to that in 2005?
Your answer should be compact. 1. What is the ratio of the Domestic credit (% of GDP) of Morocco in 2004 to that in 2005?
Ensure brevity in your answer.  0.93. What is the ratio of the Domestic credit (% of GDP) in Papua New Guinea in 2004 to that in 2005?
Provide a short and direct response. 1.1. What is the ratio of the Domestic credit (% of GDP) of Mexico in 2004 to that in 2006?
Offer a very short reply. 0.91. What is the ratio of the Domestic credit (% of GDP) of Morocco in 2004 to that in 2006?
Your answer should be very brief. 0.87. What is the ratio of the Domestic credit (% of GDP) in Papua New Guinea in 2004 to that in 2006?
Offer a terse response. 1.03. What is the ratio of the Domestic credit (% of GDP) in Mexico in 2004 to that in 2007?
Give a very brief answer. 0.85. What is the ratio of the Domestic credit (% of GDP) of Morocco in 2004 to that in 2007?
Your response must be concise. 0.79. What is the ratio of the Domestic credit (% of GDP) in Papua New Guinea in 2004 to that in 2007?
Your answer should be very brief. 1.09. What is the ratio of the Domestic credit (% of GDP) of Mexico in 2004 to that in 2008?
Offer a terse response. 0.85. What is the ratio of the Domestic credit (% of GDP) in Morocco in 2004 to that in 2008?
Your answer should be compact. 0.72. What is the ratio of the Domestic credit (% of GDP) of Papua New Guinea in 2004 to that in 2008?
Give a very brief answer. 1.08. What is the ratio of the Domestic credit (% of GDP) of Mexico in 2005 to that in 2006?
Provide a succinct answer. 0.91. What is the ratio of the Domestic credit (% of GDP) in Morocco in 2005 to that in 2006?
Your answer should be compact. 0.93. What is the ratio of the Domestic credit (% of GDP) of Papua New Guinea in 2005 to that in 2006?
Offer a very short reply. 0.94. What is the ratio of the Domestic credit (% of GDP) of Mexico in 2005 to that in 2007?
Offer a terse response. 0.85. What is the ratio of the Domestic credit (% of GDP) of Morocco in 2005 to that in 2007?
Provide a succinct answer. 0.84. What is the ratio of the Domestic credit (% of GDP) in Papua New Guinea in 2005 to that in 2007?
Give a very brief answer. 0.99. What is the ratio of the Domestic credit (% of GDP) in Mexico in 2005 to that in 2008?
Keep it short and to the point. 0.85. What is the ratio of the Domestic credit (% of GDP) of Morocco in 2005 to that in 2008?
Your response must be concise. 0.77. What is the ratio of the Domestic credit (% of GDP) in Papua New Guinea in 2005 to that in 2008?
Provide a succinct answer. 0.98. What is the ratio of the Domestic credit (% of GDP) of Mexico in 2006 to that in 2007?
Your answer should be compact. 0.93. What is the ratio of the Domestic credit (% of GDP) of Morocco in 2006 to that in 2007?
Offer a very short reply. 0.9. What is the ratio of the Domestic credit (% of GDP) of Papua New Guinea in 2006 to that in 2007?
Provide a short and direct response. 1.05. What is the ratio of the Domestic credit (% of GDP) in Mexico in 2006 to that in 2008?
Keep it short and to the point. 0.93. What is the ratio of the Domestic credit (% of GDP) of Morocco in 2006 to that in 2008?
Make the answer very short. 0.83. What is the ratio of the Domestic credit (% of GDP) in Papua New Guinea in 2006 to that in 2008?
Your answer should be compact. 1.05. What is the ratio of the Domestic credit (% of GDP) of Morocco in 2007 to that in 2008?
Keep it short and to the point. 0.92. What is the difference between the highest and the second highest Domestic credit (% of GDP) in Mexico?
Provide a succinct answer. 0.06. What is the difference between the highest and the second highest Domestic credit (% of GDP) in Morocco?
Keep it short and to the point. 7.97. What is the difference between the highest and the second highest Domestic credit (% of GDP) in Papua New Guinea?
Ensure brevity in your answer.  3.68. What is the difference between the highest and the lowest Domestic credit (% of GDP) in Mexico?
Offer a very short reply. 8.56. What is the difference between the highest and the lowest Domestic credit (% of GDP) of Morocco?
Provide a succinct answer. 26.33. What is the difference between the highest and the lowest Domestic credit (% of GDP) in Papua New Guinea?
Make the answer very short. 5.89. 